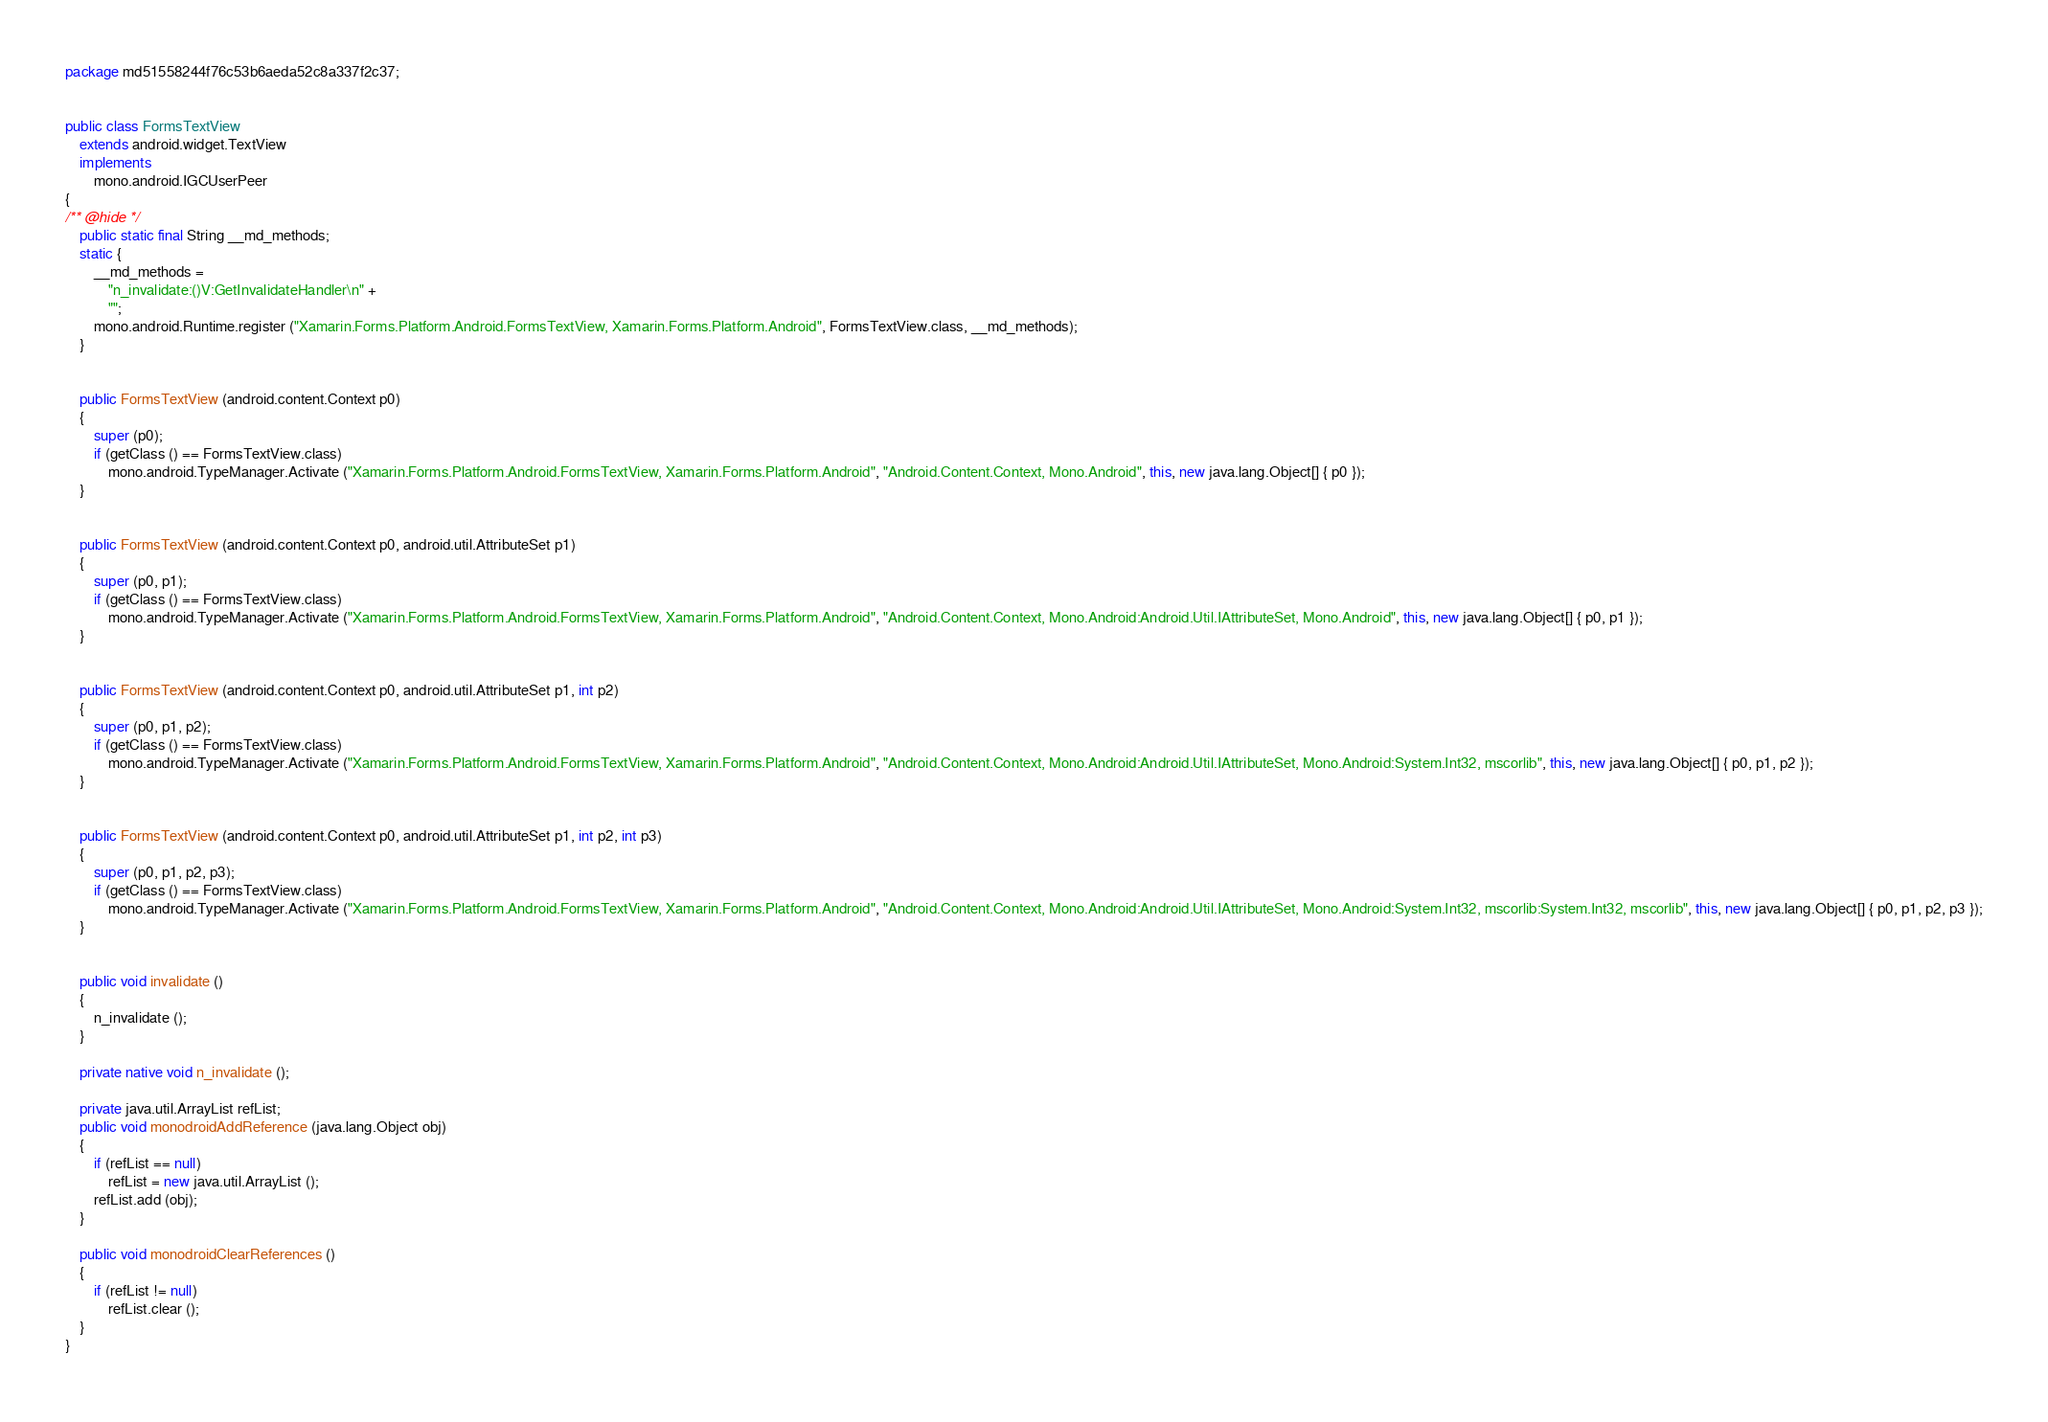Convert code to text. <code><loc_0><loc_0><loc_500><loc_500><_Java_>package md51558244f76c53b6aeda52c8a337f2c37;


public class FormsTextView
	extends android.widget.TextView
	implements
		mono.android.IGCUserPeer
{
/** @hide */
	public static final String __md_methods;
	static {
		__md_methods = 
			"n_invalidate:()V:GetInvalidateHandler\n" +
			"";
		mono.android.Runtime.register ("Xamarin.Forms.Platform.Android.FormsTextView, Xamarin.Forms.Platform.Android", FormsTextView.class, __md_methods);
	}


	public FormsTextView (android.content.Context p0)
	{
		super (p0);
		if (getClass () == FormsTextView.class)
			mono.android.TypeManager.Activate ("Xamarin.Forms.Platform.Android.FormsTextView, Xamarin.Forms.Platform.Android", "Android.Content.Context, Mono.Android", this, new java.lang.Object[] { p0 });
	}


	public FormsTextView (android.content.Context p0, android.util.AttributeSet p1)
	{
		super (p0, p1);
		if (getClass () == FormsTextView.class)
			mono.android.TypeManager.Activate ("Xamarin.Forms.Platform.Android.FormsTextView, Xamarin.Forms.Platform.Android", "Android.Content.Context, Mono.Android:Android.Util.IAttributeSet, Mono.Android", this, new java.lang.Object[] { p0, p1 });
	}


	public FormsTextView (android.content.Context p0, android.util.AttributeSet p1, int p2)
	{
		super (p0, p1, p2);
		if (getClass () == FormsTextView.class)
			mono.android.TypeManager.Activate ("Xamarin.Forms.Platform.Android.FormsTextView, Xamarin.Forms.Platform.Android", "Android.Content.Context, Mono.Android:Android.Util.IAttributeSet, Mono.Android:System.Int32, mscorlib", this, new java.lang.Object[] { p0, p1, p2 });
	}


	public FormsTextView (android.content.Context p0, android.util.AttributeSet p1, int p2, int p3)
	{
		super (p0, p1, p2, p3);
		if (getClass () == FormsTextView.class)
			mono.android.TypeManager.Activate ("Xamarin.Forms.Platform.Android.FormsTextView, Xamarin.Forms.Platform.Android", "Android.Content.Context, Mono.Android:Android.Util.IAttributeSet, Mono.Android:System.Int32, mscorlib:System.Int32, mscorlib", this, new java.lang.Object[] { p0, p1, p2, p3 });
	}


	public void invalidate ()
	{
		n_invalidate ();
	}

	private native void n_invalidate ();

	private java.util.ArrayList refList;
	public void monodroidAddReference (java.lang.Object obj)
	{
		if (refList == null)
			refList = new java.util.ArrayList ();
		refList.add (obj);
	}

	public void monodroidClearReferences ()
	{
		if (refList != null)
			refList.clear ();
	}
}
</code> 